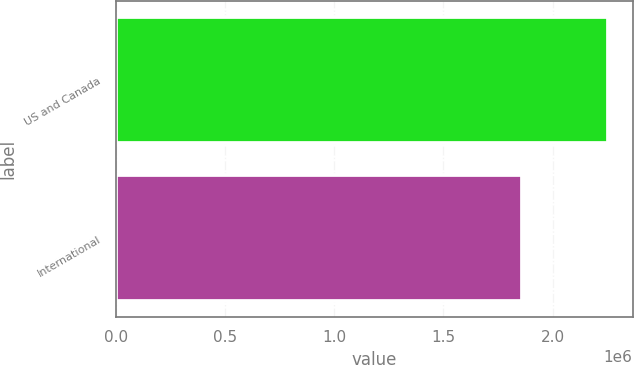Convert chart. <chart><loc_0><loc_0><loc_500><loc_500><bar_chart><fcel>US and Canada<fcel>International<nl><fcel>2.25346e+06<fcel>1.8619e+06<nl></chart> 